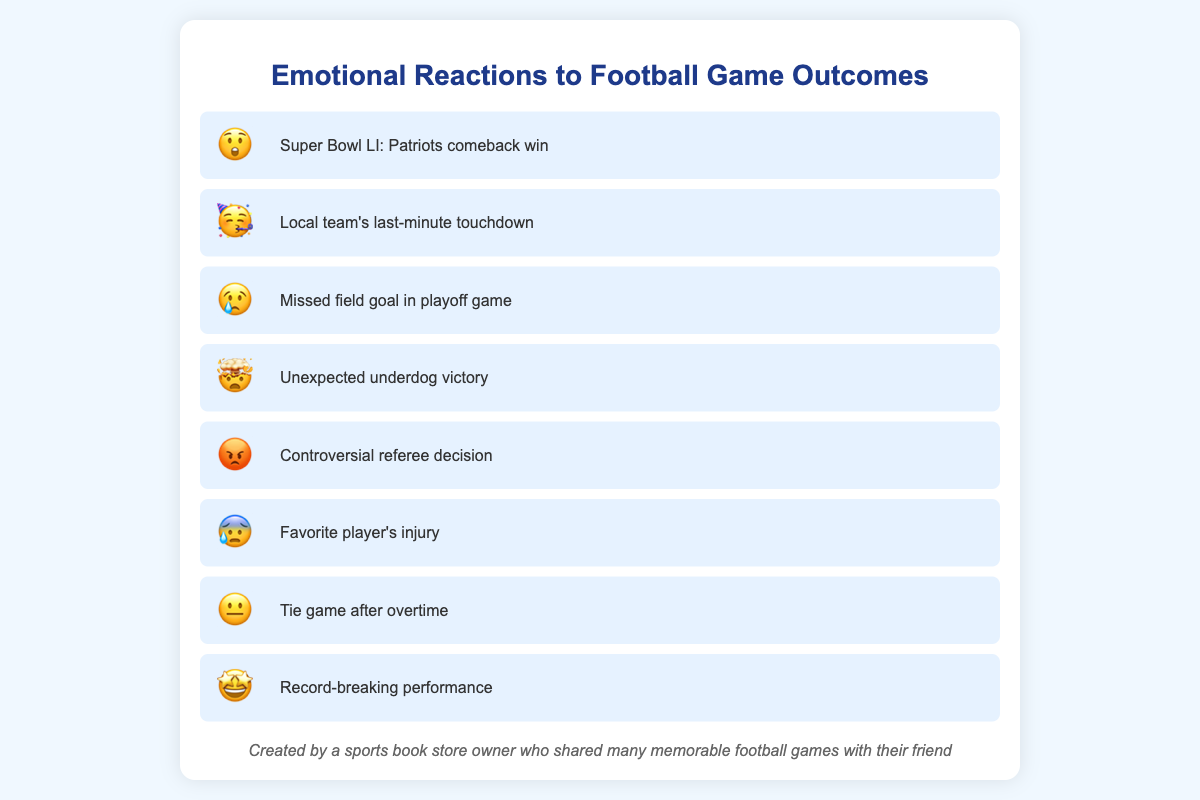Which game outcome description shows a shocked reaction? The emoji 😲 indicates a shocked reaction. Looking at the chart, the shocked emoji is next to "Super Bowl LI: Patriots comeback win."
Answer: "Super Bowl LI: Patriots comeback win" How did people feel about the local team's last-minute touchdown? The emotion next to "Local team's last-minute touchdown" is 🥳 which indicates celebration or happiness.
Answer: 🥳 What emotion corresponds to a missed field goal in a playoff game? The chart item for "Missed field goal in playoff game" has the emotion 😢, indicating sadness.
Answer: 😢 Which game outcome is associated with an angry reaction? The angry emoji 😡 is placed next to "Controversial referee decision" in the chart.
Answer: "Controversial referee decision" How many game outcomes have an excited or amazed reaction? Two outcomes have an excited or amazed reaction: "Unexpected underdog victory" with 🤯 and "Record-breaking performance" with 🤩.
Answer: 2 What is the common emotional reaction to a referee decision controversy and a favorite player's injury? The chart shows 😡 for "Controversial referee decision" and 😰 for "Favorite player's injury," indicating anger and anxiety respectively.
Answer: anger and anxiety Compare the emotional reaction between a tie game after overtime and a record-breaking performance. The reaction to a tie game after overtime is 😐, indicating indifference, while the reaction to a record-breaking performance is 🤩, indicating admiration.
Answer: Indifference and admiration Which game outcome received an indifferent reaction? 😐 is the emoji that indicates indifference, and it is paired with "Tie game after overtime."
Answer: "Tie game after overtime" What are the emotional reactions to exciting or shocking game outcomes? The chart shows 😲 for "Super Bowl LI: Patriots comeback win," 🤯 for "Unexpected underdog victory," and 🤩 for "Record-breaking performance," indicating shock, amazement, and admiration respectively.
Answer: shock, amazement, admiration Which game outcome has the emoji 😰 representing the emotion? The emoji 😰 indicates the emotion of anxiety or worry, and it is next to "Favorite player's injury" in the chart.
Answer: "Favorite player's injury" 